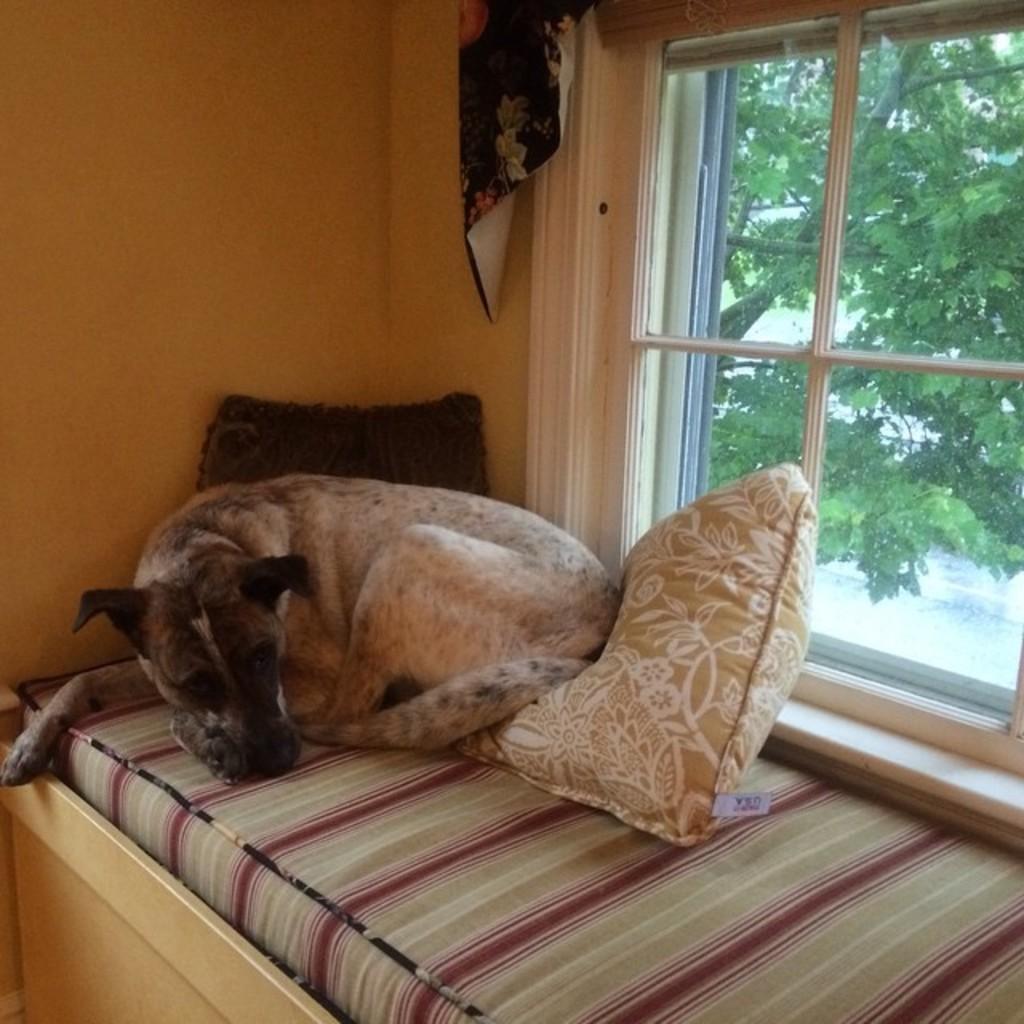Could you give a brief overview of what you see in this image? Here I can see a dog is laying on the bed. Along with this I can see two pillows. Beside this there is a window to the wall. On the top I can see a black color cloth is hanging. In the outside I can see a tree. 